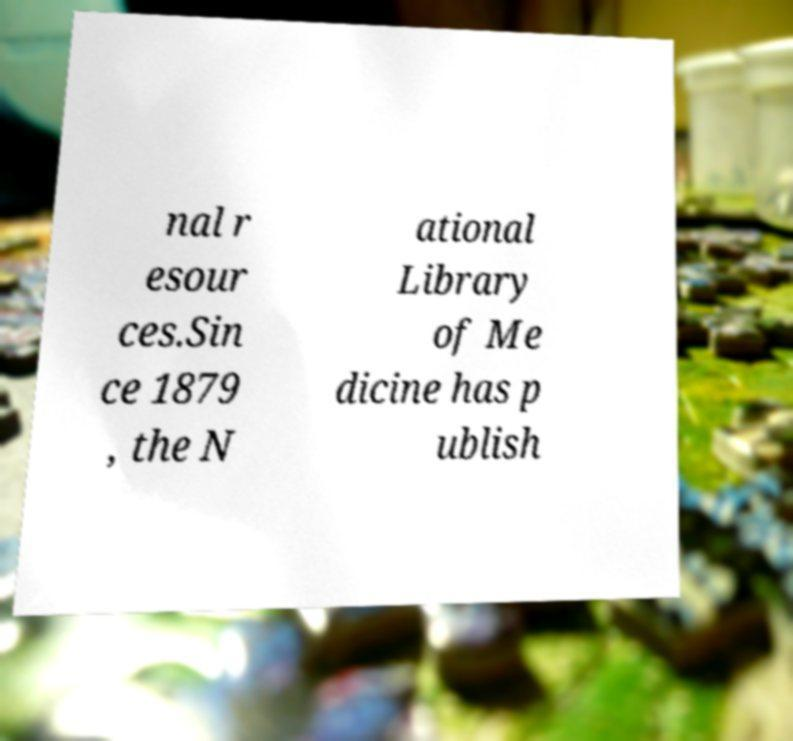Please read and relay the text visible in this image. What does it say? nal r esour ces.Sin ce 1879 , the N ational Library of Me dicine has p ublish 